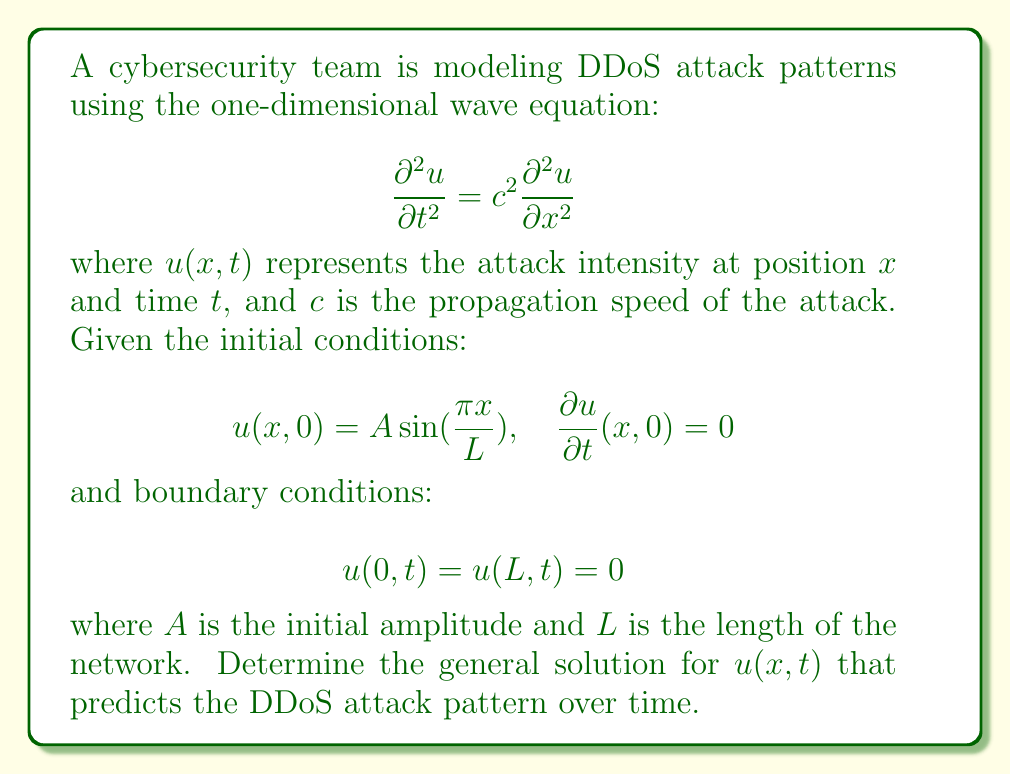Help me with this question. To solve this wave equation problem, we'll follow these steps:

1) The general solution for the wave equation with these boundary conditions is of the form:

   $$u(x,t) = \sum_{n=1}^{\infty} (A_n \cos(\omega_n t) + B_n \sin(\omega_n t)) \sin(\frac{n\pi x}{L})$$

   where $\omega_n = \frac{n\pi c}{L}$

2) Given the initial condition $\frac{\partial u}{\partial t}(x,0) = 0$, we can conclude that $B_n = 0$ for all $n$.

3) Our solution simplifies to:

   $$u(x,t) = \sum_{n=1}^{\infty} A_n \cos(\frac{n\pi c t}{L}) \sin(\frac{n\pi x}{L})$$

4) To find $A_n$, we use the other initial condition $u(x,0) = A \sin(\frac{\pi x}{L})$:

   $$A \sin(\frac{\pi x}{L}) = \sum_{n=1}^{\infty} A_n \sin(\frac{n\pi x}{L})$$

5) This implies that $A_1 = A$ and $A_n = 0$ for $n > 1$.

6) Therefore, the final solution is:

   $$u(x,t) = A \cos(\frac{\pi c t}{L}) \sin(\frac{\pi x}{L})$$

This solution represents a standing wave that oscillates in time with frequency $\frac{\pi c}{L}$ and has a spatial distribution following a sine function.
Answer: $$u(x,t) = A \cos(\frac{\pi c t}{L}) \sin(\frac{\pi x}{L})$$ 